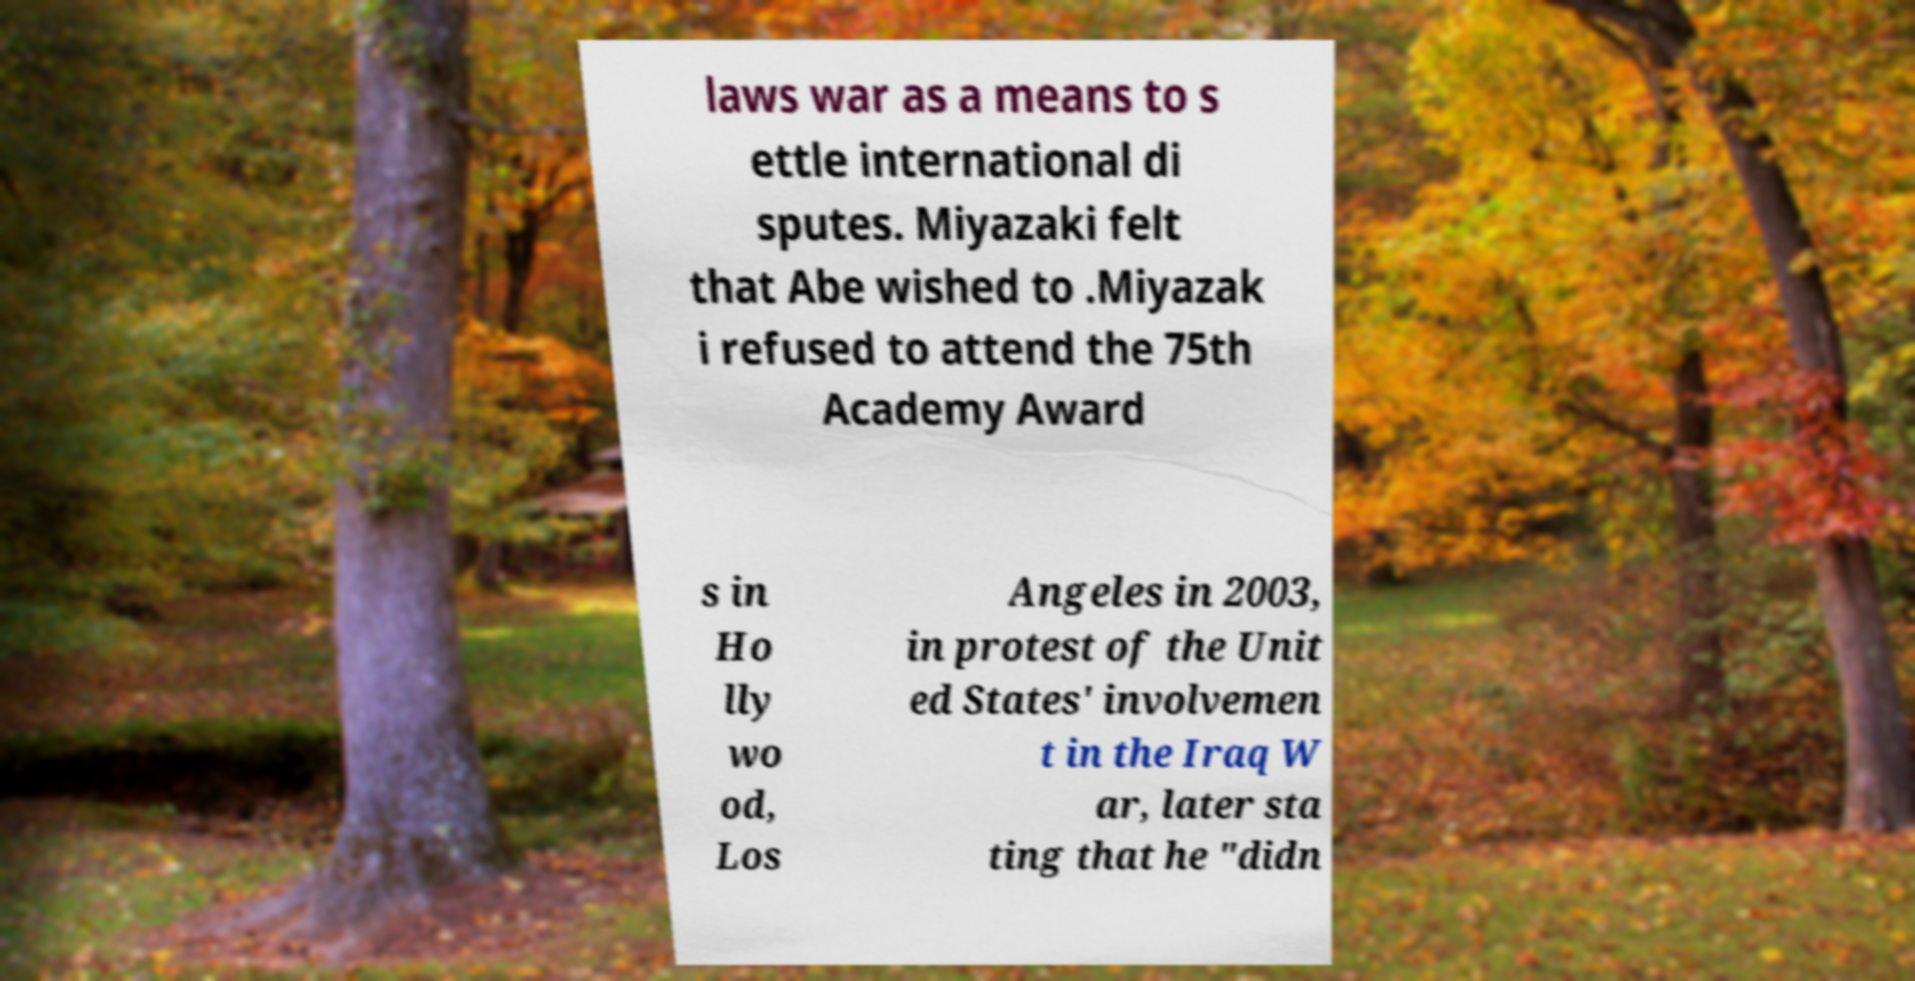For documentation purposes, I need the text within this image transcribed. Could you provide that? laws war as a means to s ettle international di sputes. Miyazaki felt that Abe wished to .Miyazak i refused to attend the 75th Academy Award s in Ho lly wo od, Los Angeles in 2003, in protest of the Unit ed States' involvemen t in the Iraq W ar, later sta ting that he "didn 